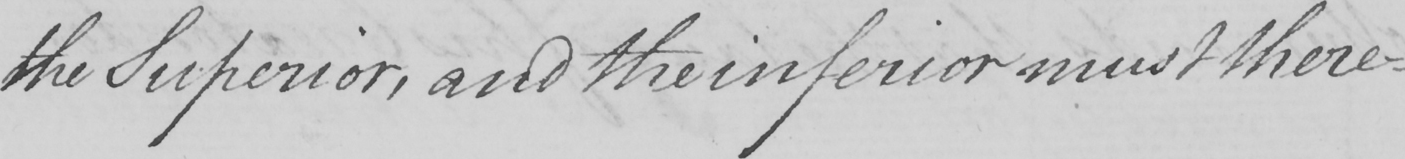Can you tell me what this handwritten text says? the Superior , and the inferior must there- 